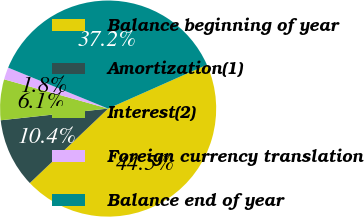Convert chart to OTSL. <chart><loc_0><loc_0><loc_500><loc_500><pie_chart><fcel>Balance beginning of year<fcel>Amortization(1)<fcel>Interest(2)<fcel>Foreign currency translation<fcel>Balance end of year<nl><fcel>44.55%<fcel>10.37%<fcel>6.09%<fcel>1.82%<fcel>37.17%<nl></chart> 